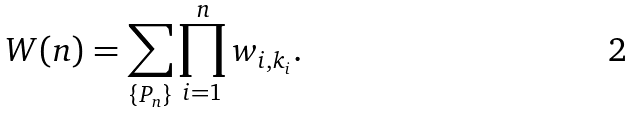<formula> <loc_0><loc_0><loc_500><loc_500>W ( n ) = \sum _ { \{ P _ { n } \} } \prod _ { i = 1 } ^ { n } w _ { i , k _ { i } } .</formula> 